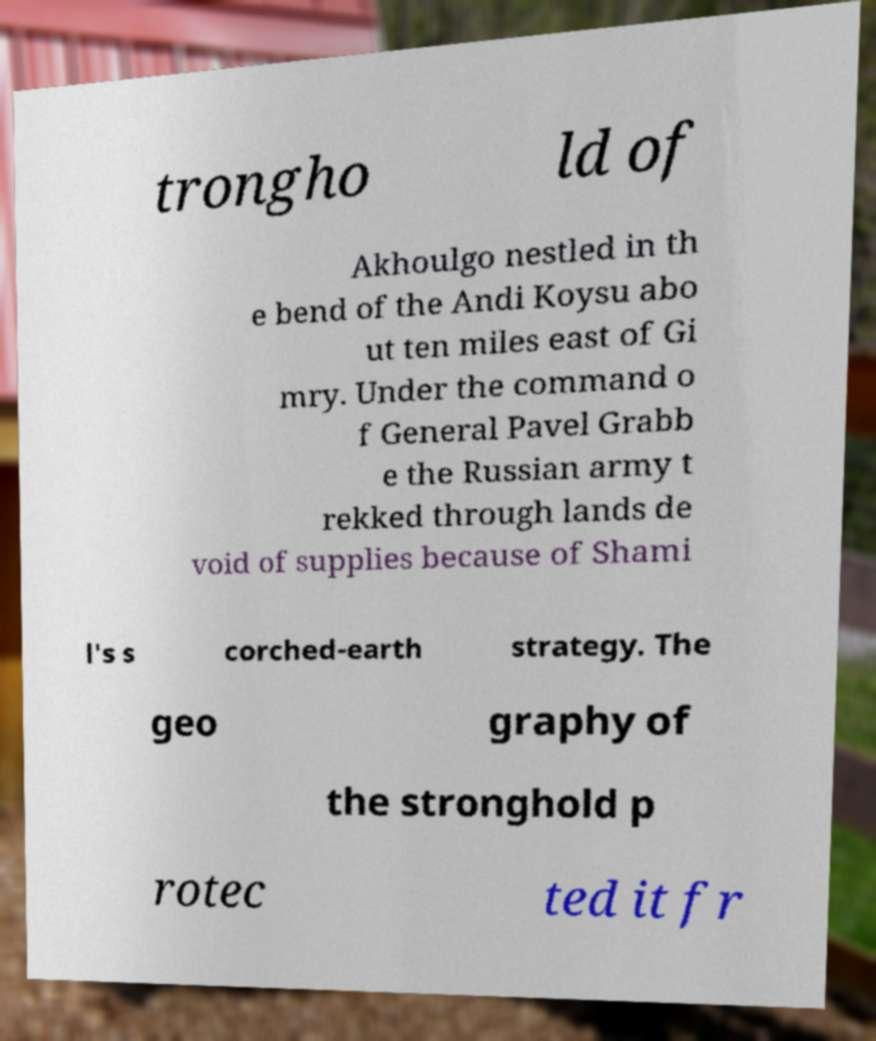What messages or text are displayed in this image? I need them in a readable, typed format. trongho ld of Akhoulgo nestled in th e bend of the Andi Koysu abo ut ten miles east of Gi mry. Under the command o f General Pavel Grabb e the Russian army t rekked through lands de void of supplies because of Shami l's s corched-earth strategy. The geo graphy of the stronghold p rotec ted it fr 